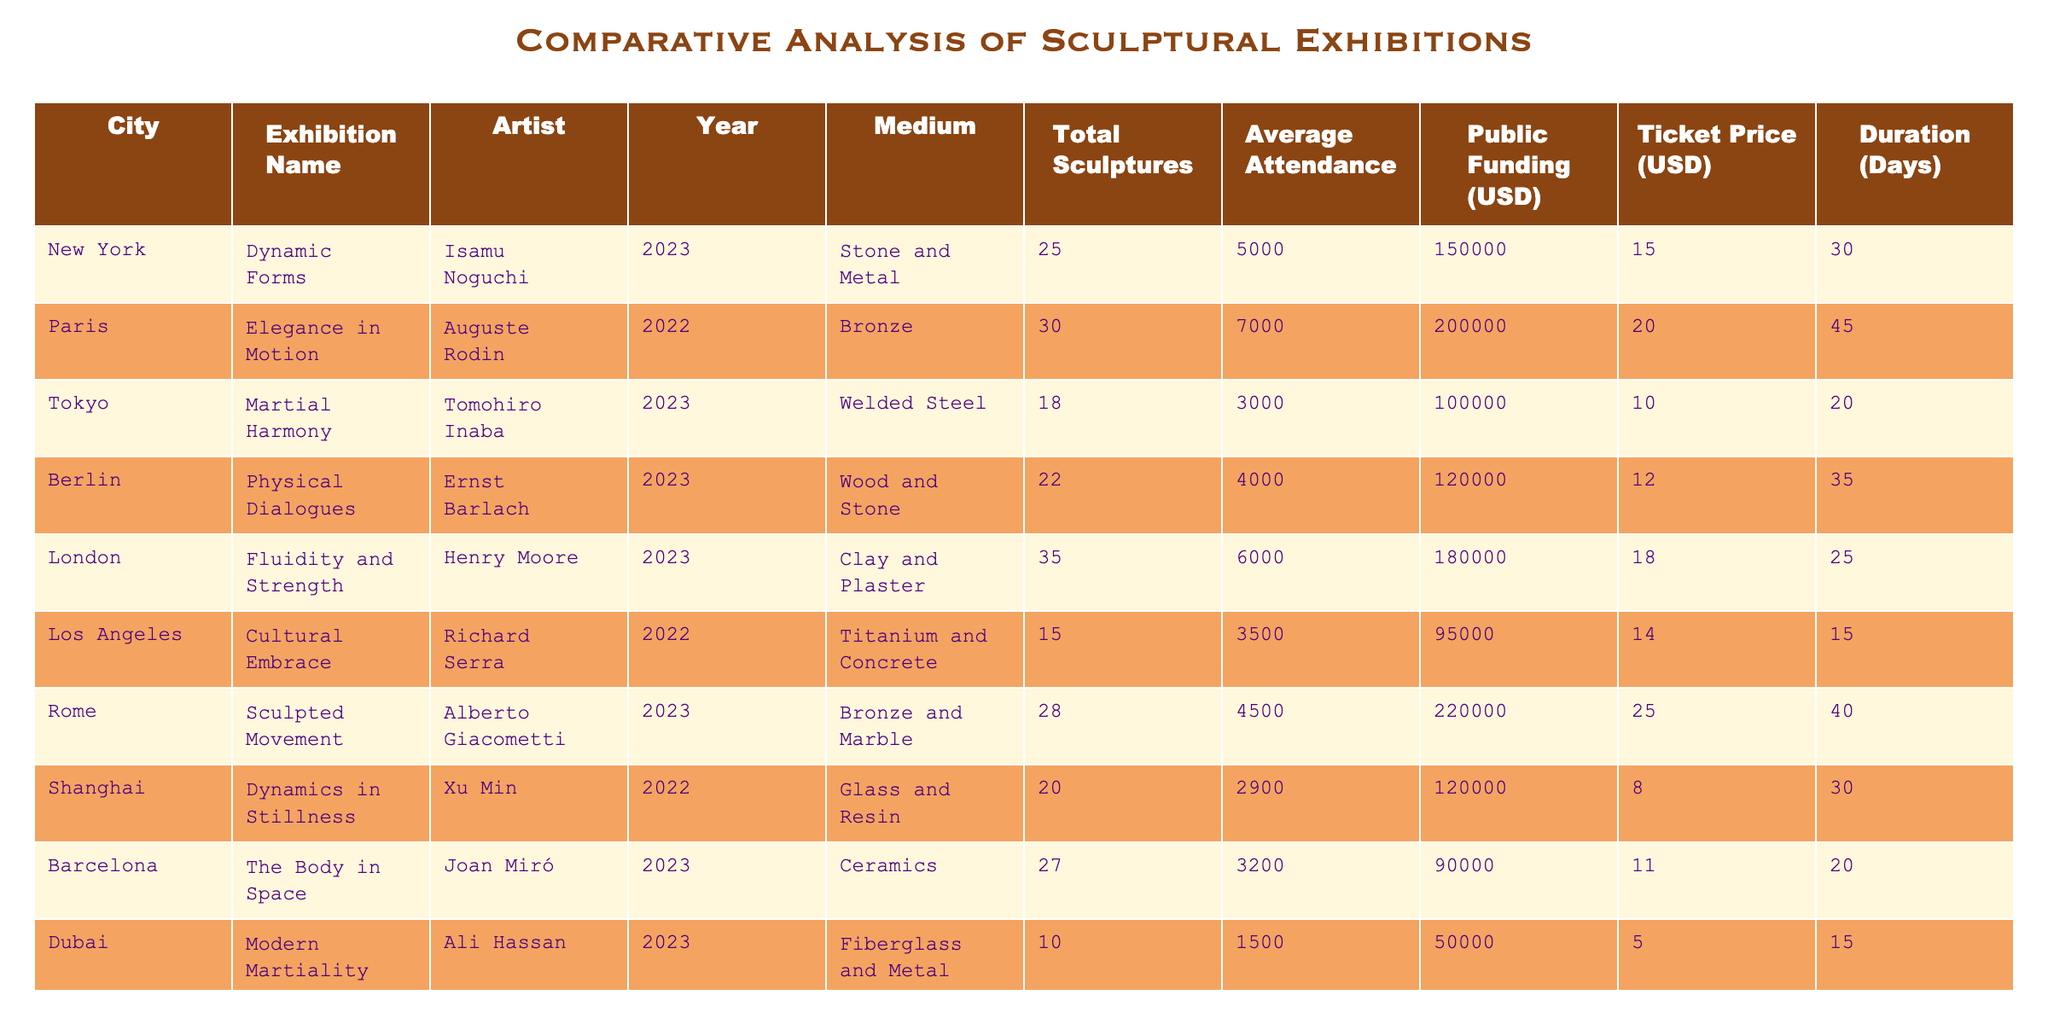What is the total public funding for the exhibition "Fluidity and Strength" in London? The table shows that the public funding for the exhibition "Fluidity and Strength" is listed under the Public Funding (USD) column for the city of London. The value is 180000 USD.
Answer: 180000 Which exhibition had the highest average attendance? By reviewing the Average Attendance column, we can note the highest value. The exhibition "Elegance in Motion" in Paris has an average attendance of 7000, which is the highest among all the exhibitions listed.
Answer: 7000 How many days did the "Cultural Embrace" exhibition in Los Angeles last for? The table provides the Duration (Days) for the exhibition "Cultural Embrace" located in Los Angeles, which is recorded as 15 days in the Duration column.
Answer: 15 What is the total ticket revenue for "Martial Harmony" in Tokyo? To find the ticket revenue, multiply the Average Attendance (3000) by the Ticket Price (10 USD): 3000 * 10 = 30000 USD. Therefore, the total ticket revenue for "Martial Harmony" is 30000 USD.
Answer: 30000 Which artist had an exhibition with the least total sculptures? Examining the Total Sculptures column, the exhibition "Modern Martiality" by Ali Hassan in Dubai has the least total sculptures at 10.
Answer: 10 Is the ticket price for any of the exhibitions higher than 20 USD? Reviewing the Ticket Price column, only "Elegance in Motion" in Paris (20 USD) meets the threshold, with other exhibitions either equal to or below that price. Thus, no exhibition has a ticket price over 20 USD.
Answer: No What is the average number of sculptures across all exhibitions? To find the average, sum all total sculptures: (25 + 30 + 18 + 22 + 35 + 15 + 28 + 20 + 27 + 10) =  210. Then divide by the number of exhibitions (10): 210 / 10 = 21. The average number of sculptures across all exhibitions is 21.
Answer: 21 Which city exhibited more sculptures: New York or Rome? Comparing the Total Sculptures for New York (25) and Rome (28), Rome has more sculptures than New York with a difference of 3 sculptures.
Answer: Rome What medium did the artist Xu Min use for their exhibition in Shanghai? The table lists the Medium for "Dynamics in Stillness" in Shanghai as Glass and Resin. Thus, the medium used by Xu Min is Glass and Resin.
Answer: Glass and Resin 